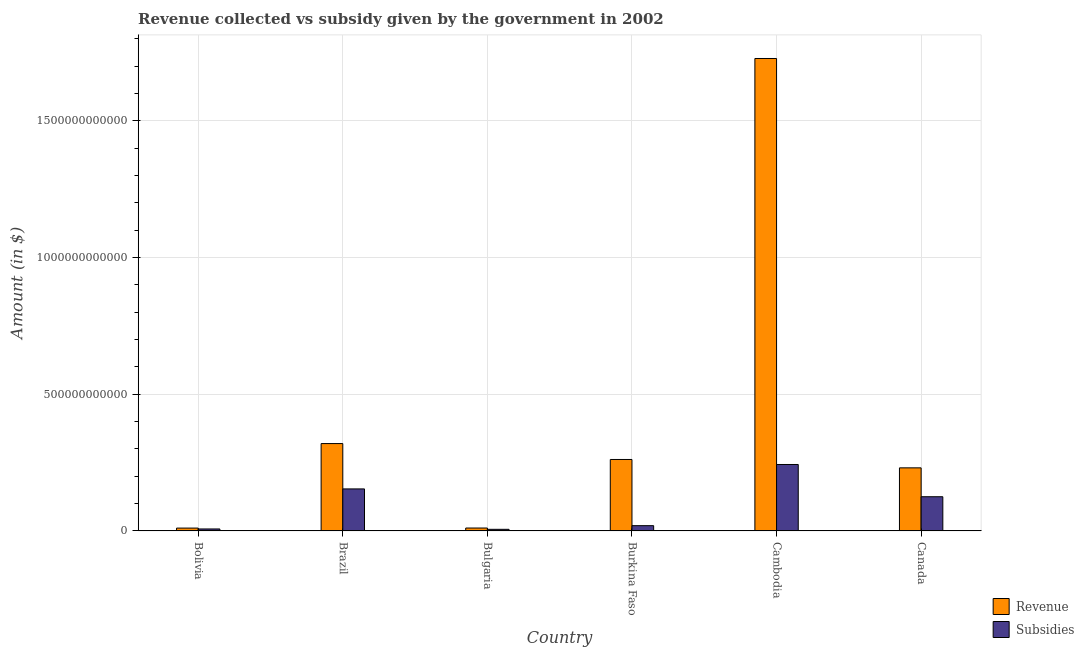How many different coloured bars are there?
Provide a succinct answer. 2. How many bars are there on the 3rd tick from the left?
Ensure brevity in your answer.  2. What is the label of the 4th group of bars from the left?
Make the answer very short. Burkina Faso. What is the amount of subsidies given in Cambodia?
Ensure brevity in your answer.  2.43e+11. Across all countries, what is the maximum amount of revenue collected?
Your answer should be very brief. 1.73e+12. Across all countries, what is the minimum amount of subsidies given?
Keep it short and to the point. 5.95e+09. In which country was the amount of subsidies given maximum?
Offer a terse response. Cambodia. In which country was the amount of subsidies given minimum?
Provide a succinct answer. Bulgaria. What is the total amount of subsidies given in the graph?
Ensure brevity in your answer.  5.54e+11. What is the difference between the amount of subsidies given in Burkina Faso and that in Cambodia?
Your answer should be compact. -2.24e+11. What is the difference between the amount of revenue collected in Cambodia and the amount of subsidies given in Brazil?
Your answer should be very brief. 1.57e+12. What is the average amount of revenue collected per country?
Keep it short and to the point. 4.27e+11. What is the difference between the amount of revenue collected and amount of subsidies given in Bulgaria?
Make the answer very short. 4.75e+09. In how many countries, is the amount of subsidies given greater than 1400000000000 $?
Provide a short and direct response. 0. What is the ratio of the amount of revenue collected in Brazil to that in Burkina Faso?
Provide a succinct answer. 1.22. What is the difference between the highest and the second highest amount of revenue collected?
Provide a succinct answer. 1.41e+12. What is the difference between the highest and the lowest amount of revenue collected?
Offer a very short reply. 1.72e+12. What does the 1st bar from the left in Burkina Faso represents?
Offer a terse response. Revenue. What does the 2nd bar from the right in Burkina Faso represents?
Provide a short and direct response. Revenue. How many bars are there?
Provide a succinct answer. 12. Are all the bars in the graph horizontal?
Keep it short and to the point. No. What is the difference between two consecutive major ticks on the Y-axis?
Provide a short and direct response. 5.00e+11. Are the values on the major ticks of Y-axis written in scientific E-notation?
Keep it short and to the point. No. Does the graph contain any zero values?
Ensure brevity in your answer.  No. Does the graph contain grids?
Keep it short and to the point. Yes. How many legend labels are there?
Provide a short and direct response. 2. How are the legend labels stacked?
Offer a terse response. Vertical. What is the title of the graph?
Provide a short and direct response. Revenue collected vs subsidy given by the government in 2002. Does "Frequency of shipment arrival" appear as one of the legend labels in the graph?
Offer a terse response. No. What is the label or title of the Y-axis?
Offer a very short reply. Amount (in $). What is the Amount (in $) of Revenue in Bolivia?
Make the answer very short. 1.04e+1. What is the Amount (in $) in Subsidies in Bolivia?
Keep it short and to the point. 7.27e+09. What is the Amount (in $) of Revenue in Brazil?
Your response must be concise. 3.19e+11. What is the Amount (in $) in Subsidies in Brazil?
Keep it short and to the point. 1.54e+11. What is the Amount (in $) of Revenue in Bulgaria?
Provide a short and direct response. 1.07e+1. What is the Amount (in $) of Subsidies in Bulgaria?
Give a very brief answer. 5.95e+09. What is the Amount (in $) of Revenue in Burkina Faso?
Offer a terse response. 2.61e+11. What is the Amount (in $) of Subsidies in Burkina Faso?
Provide a succinct answer. 1.93e+1. What is the Amount (in $) of Revenue in Cambodia?
Provide a succinct answer. 1.73e+12. What is the Amount (in $) in Subsidies in Cambodia?
Your answer should be very brief. 2.43e+11. What is the Amount (in $) in Revenue in Canada?
Provide a succinct answer. 2.31e+11. What is the Amount (in $) in Subsidies in Canada?
Offer a terse response. 1.25e+11. Across all countries, what is the maximum Amount (in $) of Revenue?
Your answer should be compact. 1.73e+12. Across all countries, what is the maximum Amount (in $) in Subsidies?
Provide a succinct answer. 2.43e+11. Across all countries, what is the minimum Amount (in $) of Revenue?
Make the answer very short. 1.04e+1. Across all countries, what is the minimum Amount (in $) of Subsidies?
Make the answer very short. 5.95e+09. What is the total Amount (in $) of Revenue in the graph?
Ensure brevity in your answer.  2.56e+12. What is the total Amount (in $) in Subsidies in the graph?
Your answer should be compact. 5.54e+11. What is the difference between the Amount (in $) in Revenue in Bolivia and that in Brazil?
Give a very brief answer. -3.09e+11. What is the difference between the Amount (in $) in Subsidies in Bolivia and that in Brazil?
Make the answer very short. -1.46e+11. What is the difference between the Amount (in $) of Revenue in Bolivia and that in Bulgaria?
Ensure brevity in your answer.  -2.76e+08. What is the difference between the Amount (in $) in Subsidies in Bolivia and that in Bulgaria?
Give a very brief answer. 1.32e+09. What is the difference between the Amount (in $) in Revenue in Bolivia and that in Burkina Faso?
Provide a succinct answer. -2.51e+11. What is the difference between the Amount (in $) of Subsidies in Bolivia and that in Burkina Faso?
Make the answer very short. -1.21e+1. What is the difference between the Amount (in $) in Revenue in Bolivia and that in Cambodia?
Provide a short and direct response. -1.72e+12. What is the difference between the Amount (in $) in Subsidies in Bolivia and that in Cambodia?
Ensure brevity in your answer.  -2.36e+11. What is the difference between the Amount (in $) in Revenue in Bolivia and that in Canada?
Make the answer very short. -2.20e+11. What is the difference between the Amount (in $) in Subsidies in Bolivia and that in Canada?
Your response must be concise. -1.18e+11. What is the difference between the Amount (in $) in Revenue in Brazil and that in Bulgaria?
Give a very brief answer. 3.09e+11. What is the difference between the Amount (in $) in Subsidies in Brazil and that in Bulgaria?
Ensure brevity in your answer.  1.48e+11. What is the difference between the Amount (in $) of Revenue in Brazil and that in Burkina Faso?
Your answer should be compact. 5.82e+1. What is the difference between the Amount (in $) in Subsidies in Brazil and that in Burkina Faso?
Your answer should be very brief. 1.34e+11. What is the difference between the Amount (in $) in Revenue in Brazil and that in Cambodia?
Ensure brevity in your answer.  -1.41e+12. What is the difference between the Amount (in $) of Subsidies in Brazil and that in Cambodia?
Offer a very short reply. -8.93e+1. What is the difference between the Amount (in $) of Revenue in Brazil and that in Canada?
Your answer should be compact. 8.88e+1. What is the difference between the Amount (in $) of Subsidies in Brazil and that in Canada?
Give a very brief answer. 2.86e+1. What is the difference between the Amount (in $) of Revenue in Bulgaria and that in Burkina Faso?
Give a very brief answer. -2.51e+11. What is the difference between the Amount (in $) of Subsidies in Bulgaria and that in Burkina Faso?
Provide a succinct answer. -1.34e+1. What is the difference between the Amount (in $) in Revenue in Bulgaria and that in Cambodia?
Keep it short and to the point. -1.72e+12. What is the difference between the Amount (in $) in Subsidies in Bulgaria and that in Cambodia?
Provide a short and direct response. -2.37e+11. What is the difference between the Amount (in $) of Revenue in Bulgaria and that in Canada?
Keep it short and to the point. -2.20e+11. What is the difference between the Amount (in $) of Subsidies in Bulgaria and that in Canada?
Your answer should be compact. -1.19e+11. What is the difference between the Amount (in $) in Revenue in Burkina Faso and that in Cambodia?
Your response must be concise. -1.47e+12. What is the difference between the Amount (in $) in Subsidies in Burkina Faso and that in Cambodia?
Provide a short and direct response. -2.24e+11. What is the difference between the Amount (in $) of Revenue in Burkina Faso and that in Canada?
Your response must be concise. 3.06e+1. What is the difference between the Amount (in $) in Subsidies in Burkina Faso and that in Canada?
Your answer should be very brief. -1.06e+11. What is the difference between the Amount (in $) of Revenue in Cambodia and that in Canada?
Your answer should be compact. 1.50e+12. What is the difference between the Amount (in $) of Subsidies in Cambodia and that in Canada?
Keep it short and to the point. 1.18e+11. What is the difference between the Amount (in $) in Revenue in Bolivia and the Amount (in $) in Subsidies in Brazil?
Your answer should be very brief. -1.43e+11. What is the difference between the Amount (in $) of Revenue in Bolivia and the Amount (in $) of Subsidies in Bulgaria?
Keep it short and to the point. 4.47e+09. What is the difference between the Amount (in $) of Revenue in Bolivia and the Amount (in $) of Subsidies in Burkina Faso?
Provide a short and direct response. -8.90e+09. What is the difference between the Amount (in $) in Revenue in Bolivia and the Amount (in $) in Subsidies in Cambodia?
Offer a very short reply. -2.33e+11. What is the difference between the Amount (in $) of Revenue in Bolivia and the Amount (in $) of Subsidies in Canada?
Keep it short and to the point. -1.15e+11. What is the difference between the Amount (in $) in Revenue in Brazil and the Amount (in $) in Subsidies in Bulgaria?
Your answer should be very brief. 3.14e+11. What is the difference between the Amount (in $) of Revenue in Brazil and the Amount (in $) of Subsidies in Burkina Faso?
Give a very brief answer. 3.00e+11. What is the difference between the Amount (in $) of Revenue in Brazil and the Amount (in $) of Subsidies in Cambodia?
Provide a succinct answer. 7.65e+1. What is the difference between the Amount (in $) of Revenue in Brazil and the Amount (in $) of Subsidies in Canada?
Your response must be concise. 1.94e+11. What is the difference between the Amount (in $) in Revenue in Bulgaria and the Amount (in $) in Subsidies in Burkina Faso?
Keep it short and to the point. -8.63e+09. What is the difference between the Amount (in $) of Revenue in Bulgaria and the Amount (in $) of Subsidies in Cambodia?
Your answer should be very brief. -2.32e+11. What is the difference between the Amount (in $) in Revenue in Bulgaria and the Amount (in $) in Subsidies in Canada?
Provide a short and direct response. -1.14e+11. What is the difference between the Amount (in $) of Revenue in Burkina Faso and the Amount (in $) of Subsidies in Cambodia?
Provide a short and direct response. 1.83e+1. What is the difference between the Amount (in $) in Revenue in Burkina Faso and the Amount (in $) in Subsidies in Canada?
Your response must be concise. 1.36e+11. What is the difference between the Amount (in $) of Revenue in Cambodia and the Amount (in $) of Subsidies in Canada?
Keep it short and to the point. 1.60e+12. What is the average Amount (in $) of Revenue per country?
Your answer should be compact. 4.27e+11. What is the average Amount (in $) of Subsidies per country?
Provide a succinct answer. 9.24e+1. What is the difference between the Amount (in $) of Revenue and Amount (in $) of Subsidies in Bolivia?
Ensure brevity in your answer.  3.15e+09. What is the difference between the Amount (in $) in Revenue and Amount (in $) in Subsidies in Brazil?
Provide a succinct answer. 1.66e+11. What is the difference between the Amount (in $) of Revenue and Amount (in $) of Subsidies in Bulgaria?
Keep it short and to the point. 4.75e+09. What is the difference between the Amount (in $) of Revenue and Amount (in $) of Subsidies in Burkina Faso?
Give a very brief answer. 2.42e+11. What is the difference between the Amount (in $) of Revenue and Amount (in $) of Subsidies in Cambodia?
Offer a very short reply. 1.48e+12. What is the difference between the Amount (in $) in Revenue and Amount (in $) in Subsidies in Canada?
Give a very brief answer. 1.06e+11. What is the ratio of the Amount (in $) in Revenue in Bolivia to that in Brazil?
Your answer should be compact. 0.03. What is the ratio of the Amount (in $) of Subsidies in Bolivia to that in Brazil?
Provide a short and direct response. 0.05. What is the ratio of the Amount (in $) in Revenue in Bolivia to that in Bulgaria?
Your answer should be very brief. 0.97. What is the ratio of the Amount (in $) in Subsidies in Bolivia to that in Bulgaria?
Keep it short and to the point. 1.22. What is the ratio of the Amount (in $) of Revenue in Bolivia to that in Burkina Faso?
Make the answer very short. 0.04. What is the ratio of the Amount (in $) of Subsidies in Bolivia to that in Burkina Faso?
Ensure brevity in your answer.  0.38. What is the ratio of the Amount (in $) of Revenue in Bolivia to that in Cambodia?
Keep it short and to the point. 0.01. What is the ratio of the Amount (in $) of Subsidies in Bolivia to that in Cambodia?
Provide a succinct answer. 0.03. What is the ratio of the Amount (in $) in Revenue in Bolivia to that in Canada?
Keep it short and to the point. 0.05. What is the ratio of the Amount (in $) of Subsidies in Bolivia to that in Canada?
Provide a short and direct response. 0.06. What is the ratio of the Amount (in $) of Revenue in Brazil to that in Bulgaria?
Your answer should be compact. 29.88. What is the ratio of the Amount (in $) of Subsidies in Brazil to that in Bulgaria?
Offer a very short reply. 25.84. What is the ratio of the Amount (in $) of Revenue in Brazil to that in Burkina Faso?
Give a very brief answer. 1.22. What is the ratio of the Amount (in $) of Subsidies in Brazil to that in Burkina Faso?
Keep it short and to the point. 7.96. What is the ratio of the Amount (in $) in Revenue in Brazil to that in Cambodia?
Provide a succinct answer. 0.18. What is the ratio of the Amount (in $) in Subsidies in Brazil to that in Cambodia?
Offer a very short reply. 0.63. What is the ratio of the Amount (in $) of Revenue in Brazil to that in Canada?
Offer a terse response. 1.38. What is the ratio of the Amount (in $) of Subsidies in Brazil to that in Canada?
Offer a terse response. 1.23. What is the ratio of the Amount (in $) in Revenue in Bulgaria to that in Burkina Faso?
Ensure brevity in your answer.  0.04. What is the ratio of the Amount (in $) in Subsidies in Bulgaria to that in Burkina Faso?
Make the answer very short. 0.31. What is the ratio of the Amount (in $) of Revenue in Bulgaria to that in Cambodia?
Offer a very short reply. 0.01. What is the ratio of the Amount (in $) in Subsidies in Bulgaria to that in Cambodia?
Provide a short and direct response. 0.02. What is the ratio of the Amount (in $) of Revenue in Bulgaria to that in Canada?
Your response must be concise. 0.05. What is the ratio of the Amount (in $) in Subsidies in Bulgaria to that in Canada?
Your answer should be compact. 0.05. What is the ratio of the Amount (in $) in Revenue in Burkina Faso to that in Cambodia?
Give a very brief answer. 0.15. What is the ratio of the Amount (in $) of Subsidies in Burkina Faso to that in Cambodia?
Keep it short and to the point. 0.08. What is the ratio of the Amount (in $) in Revenue in Burkina Faso to that in Canada?
Offer a terse response. 1.13. What is the ratio of the Amount (in $) of Subsidies in Burkina Faso to that in Canada?
Provide a succinct answer. 0.15. What is the ratio of the Amount (in $) of Revenue in Cambodia to that in Canada?
Provide a short and direct response. 7.49. What is the ratio of the Amount (in $) in Subsidies in Cambodia to that in Canada?
Keep it short and to the point. 1.94. What is the difference between the highest and the second highest Amount (in $) of Revenue?
Offer a very short reply. 1.41e+12. What is the difference between the highest and the second highest Amount (in $) of Subsidies?
Make the answer very short. 8.93e+1. What is the difference between the highest and the lowest Amount (in $) of Revenue?
Make the answer very short. 1.72e+12. What is the difference between the highest and the lowest Amount (in $) of Subsidies?
Give a very brief answer. 2.37e+11. 